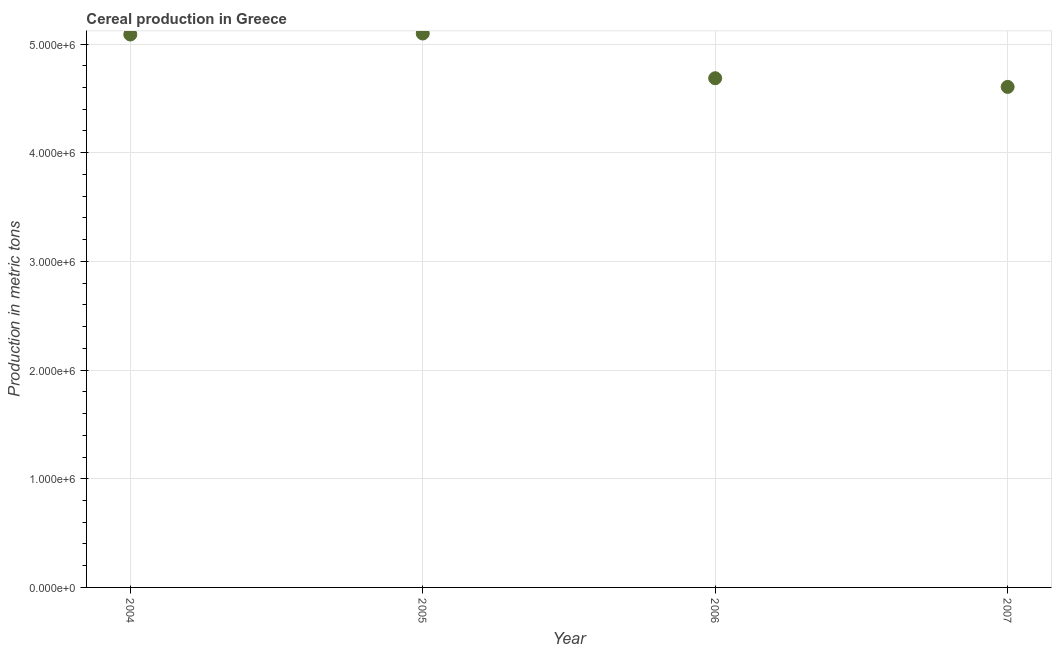What is the cereal production in 2006?
Your answer should be very brief. 4.69e+06. Across all years, what is the maximum cereal production?
Give a very brief answer. 5.10e+06. Across all years, what is the minimum cereal production?
Ensure brevity in your answer.  4.61e+06. In which year was the cereal production minimum?
Your answer should be compact. 2007. What is the sum of the cereal production?
Offer a terse response. 1.95e+07. What is the difference between the cereal production in 2006 and 2007?
Make the answer very short. 7.98e+04. What is the average cereal production per year?
Your answer should be compact. 4.87e+06. What is the median cereal production?
Provide a succinct answer. 4.89e+06. In how many years, is the cereal production greater than 2400000 metric tons?
Your answer should be very brief. 4. Do a majority of the years between 2005 and 2004 (inclusive) have cereal production greater than 800000 metric tons?
Provide a short and direct response. No. What is the ratio of the cereal production in 2004 to that in 2007?
Make the answer very short. 1.1. Is the cereal production in 2005 less than that in 2006?
Your answer should be very brief. No. What is the difference between the highest and the second highest cereal production?
Ensure brevity in your answer.  9335. What is the difference between the highest and the lowest cereal production?
Provide a succinct answer. 4.91e+05. In how many years, is the cereal production greater than the average cereal production taken over all years?
Keep it short and to the point. 2. Are the values on the major ticks of Y-axis written in scientific E-notation?
Provide a succinct answer. Yes. Does the graph contain any zero values?
Your answer should be compact. No. Does the graph contain grids?
Give a very brief answer. Yes. What is the title of the graph?
Offer a very short reply. Cereal production in Greece. What is the label or title of the X-axis?
Give a very brief answer. Year. What is the label or title of the Y-axis?
Provide a succinct answer. Production in metric tons. What is the Production in metric tons in 2004?
Provide a short and direct response. 5.09e+06. What is the Production in metric tons in 2005?
Offer a very short reply. 5.10e+06. What is the Production in metric tons in 2006?
Keep it short and to the point. 4.69e+06. What is the Production in metric tons in 2007?
Make the answer very short. 4.61e+06. What is the difference between the Production in metric tons in 2004 and 2005?
Provide a short and direct response. -9335. What is the difference between the Production in metric tons in 2004 and 2006?
Ensure brevity in your answer.  4.02e+05. What is the difference between the Production in metric tons in 2004 and 2007?
Your response must be concise. 4.82e+05. What is the difference between the Production in metric tons in 2005 and 2006?
Make the answer very short. 4.12e+05. What is the difference between the Production in metric tons in 2005 and 2007?
Ensure brevity in your answer.  4.91e+05. What is the difference between the Production in metric tons in 2006 and 2007?
Keep it short and to the point. 7.98e+04. What is the ratio of the Production in metric tons in 2004 to that in 2005?
Make the answer very short. 1. What is the ratio of the Production in metric tons in 2004 to that in 2006?
Keep it short and to the point. 1.09. What is the ratio of the Production in metric tons in 2004 to that in 2007?
Keep it short and to the point. 1.1. What is the ratio of the Production in metric tons in 2005 to that in 2006?
Ensure brevity in your answer.  1.09. What is the ratio of the Production in metric tons in 2005 to that in 2007?
Provide a succinct answer. 1.11. 